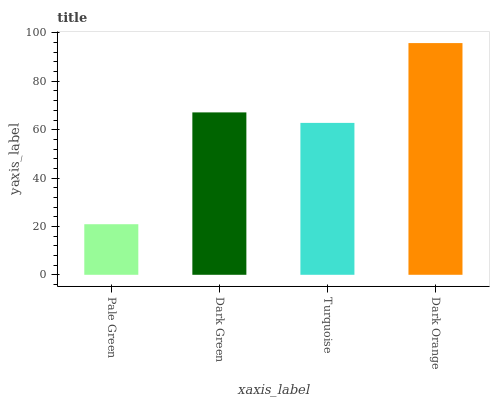Is Pale Green the minimum?
Answer yes or no. Yes. Is Dark Orange the maximum?
Answer yes or no. Yes. Is Dark Green the minimum?
Answer yes or no. No. Is Dark Green the maximum?
Answer yes or no. No. Is Dark Green greater than Pale Green?
Answer yes or no. Yes. Is Pale Green less than Dark Green?
Answer yes or no. Yes. Is Pale Green greater than Dark Green?
Answer yes or no. No. Is Dark Green less than Pale Green?
Answer yes or no. No. Is Dark Green the high median?
Answer yes or no. Yes. Is Turquoise the low median?
Answer yes or no. Yes. Is Turquoise the high median?
Answer yes or no. No. Is Dark Orange the low median?
Answer yes or no. No. 